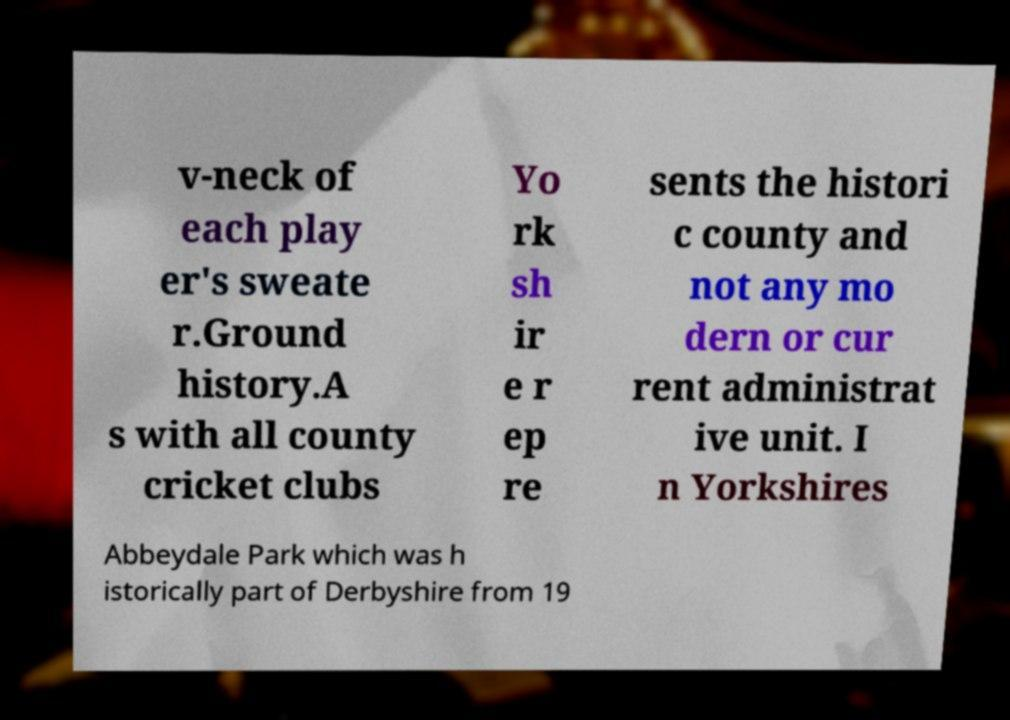I need the written content from this picture converted into text. Can you do that? v-neck of each play er's sweate r.Ground history.A s with all county cricket clubs Yo rk sh ir e r ep re sents the histori c county and not any mo dern or cur rent administrat ive unit. I n Yorkshires Abbeydale Park which was h istorically part of Derbyshire from 19 